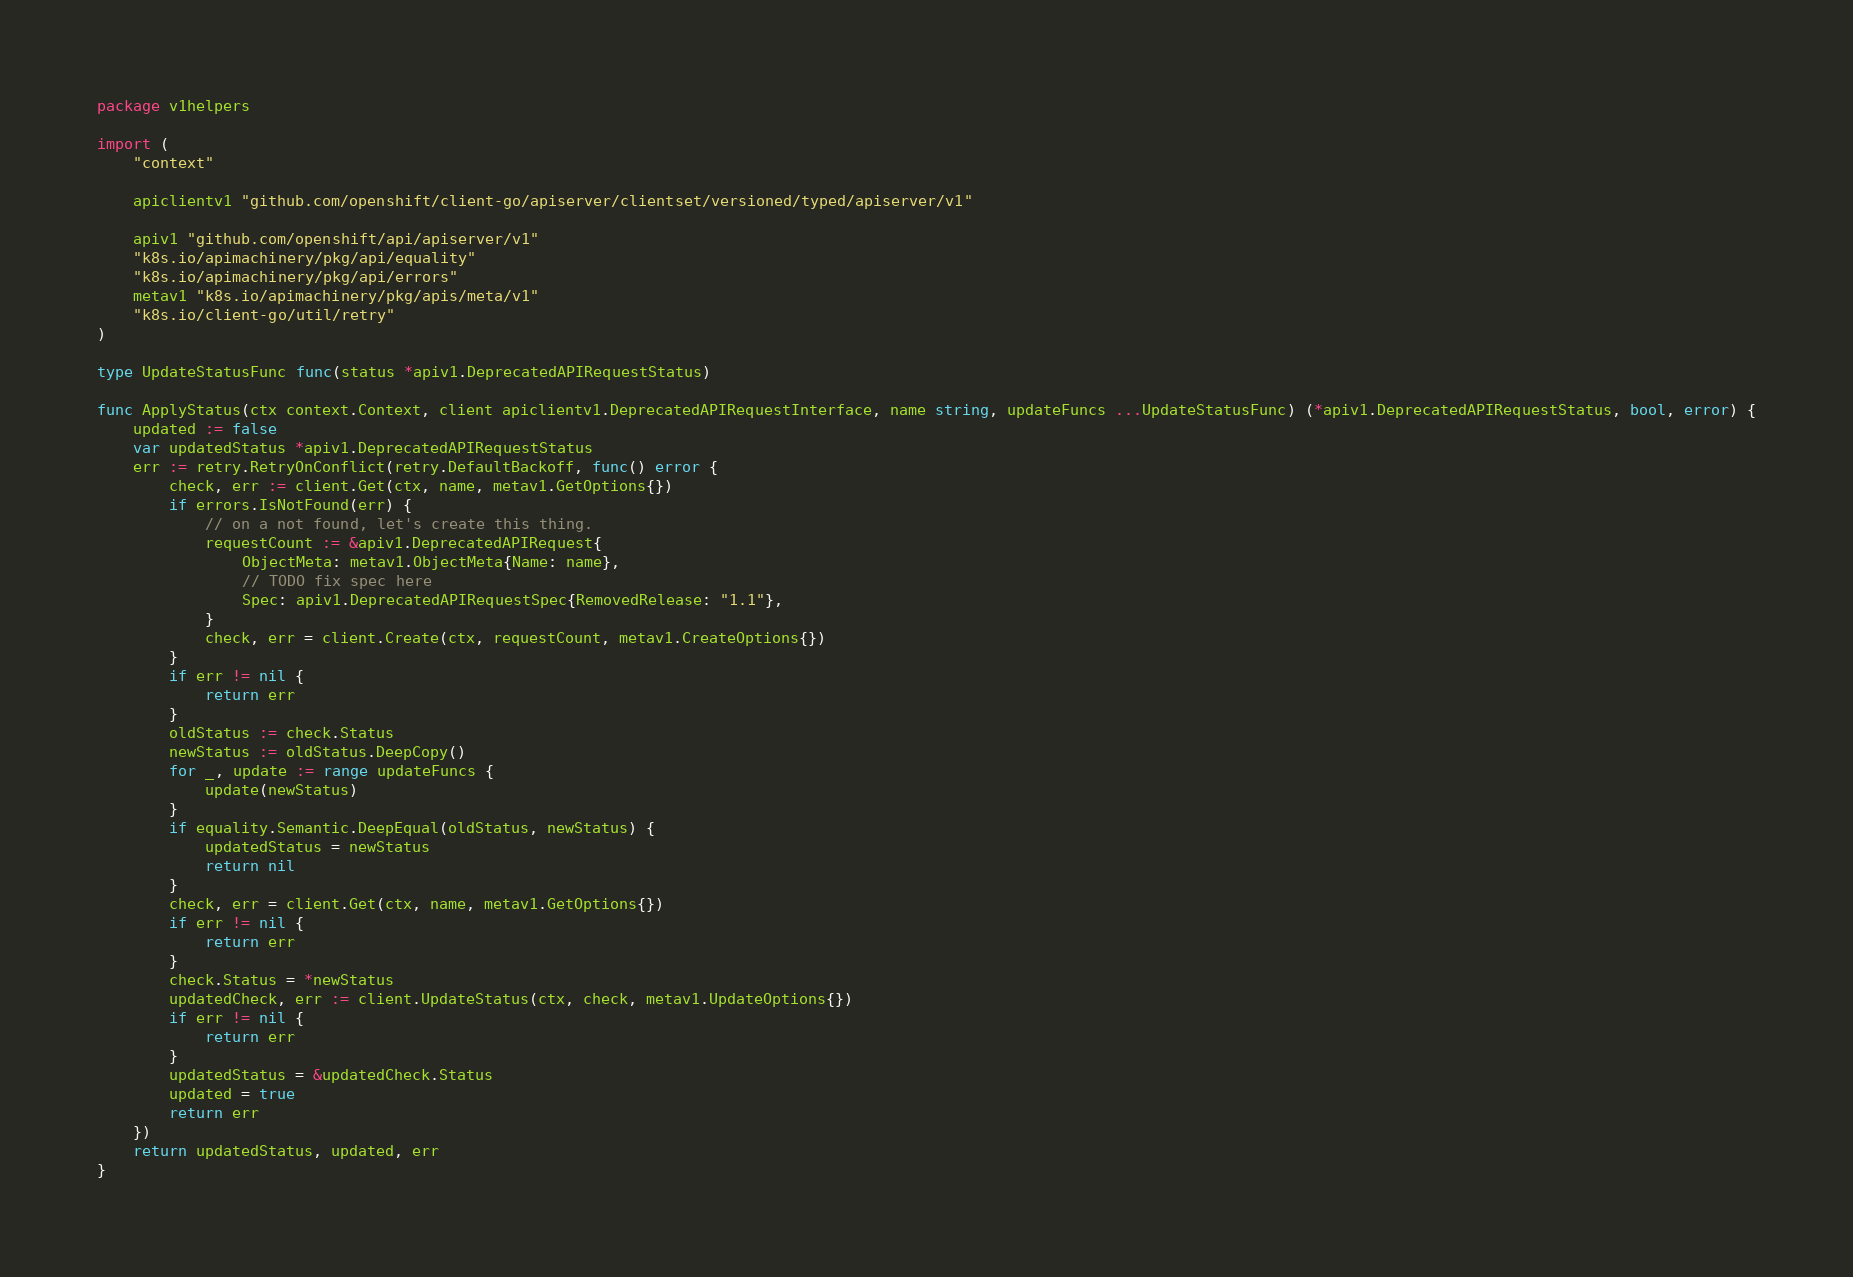<code> <loc_0><loc_0><loc_500><loc_500><_Go_>package v1helpers

import (
	"context"

	apiclientv1 "github.com/openshift/client-go/apiserver/clientset/versioned/typed/apiserver/v1"

	apiv1 "github.com/openshift/api/apiserver/v1"
	"k8s.io/apimachinery/pkg/api/equality"
	"k8s.io/apimachinery/pkg/api/errors"
	metav1 "k8s.io/apimachinery/pkg/apis/meta/v1"
	"k8s.io/client-go/util/retry"
)

type UpdateStatusFunc func(status *apiv1.DeprecatedAPIRequestStatus)

func ApplyStatus(ctx context.Context, client apiclientv1.DeprecatedAPIRequestInterface, name string, updateFuncs ...UpdateStatusFunc) (*apiv1.DeprecatedAPIRequestStatus, bool, error) {
	updated := false
	var updatedStatus *apiv1.DeprecatedAPIRequestStatus
	err := retry.RetryOnConflict(retry.DefaultBackoff, func() error {
		check, err := client.Get(ctx, name, metav1.GetOptions{})
		if errors.IsNotFound(err) {
			// on a not found, let's create this thing.
			requestCount := &apiv1.DeprecatedAPIRequest{
				ObjectMeta: metav1.ObjectMeta{Name: name},
				// TODO fix spec here
				Spec: apiv1.DeprecatedAPIRequestSpec{RemovedRelease: "1.1"},
			}
			check, err = client.Create(ctx, requestCount, metav1.CreateOptions{})
		}
		if err != nil {
			return err
		}
		oldStatus := check.Status
		newStatus := oldStatus.DeepCopy()
		for _, update := range updateFuncs {
			update(newStatus)
		}
		if equality.Semantic.DeepEqual(oldStatus, newStatus) {
			updatedStatus = newStatus
			return nil
		}
		check, err = client.Get(ctx, name, metav1.GetOptions{})
		if err != nil {
			return err
		}
		check.Status = *newStatus
		updatedCheck, err := client.UpdateStatus(ctx, check, metav1.UpdateOptions{})
		if err != nil {
			return err
		}
		updatedStatus = &updatedCheck.Status
		updated = true
		return err
	})
	return updatedStatus, updated, err
}
</code> 